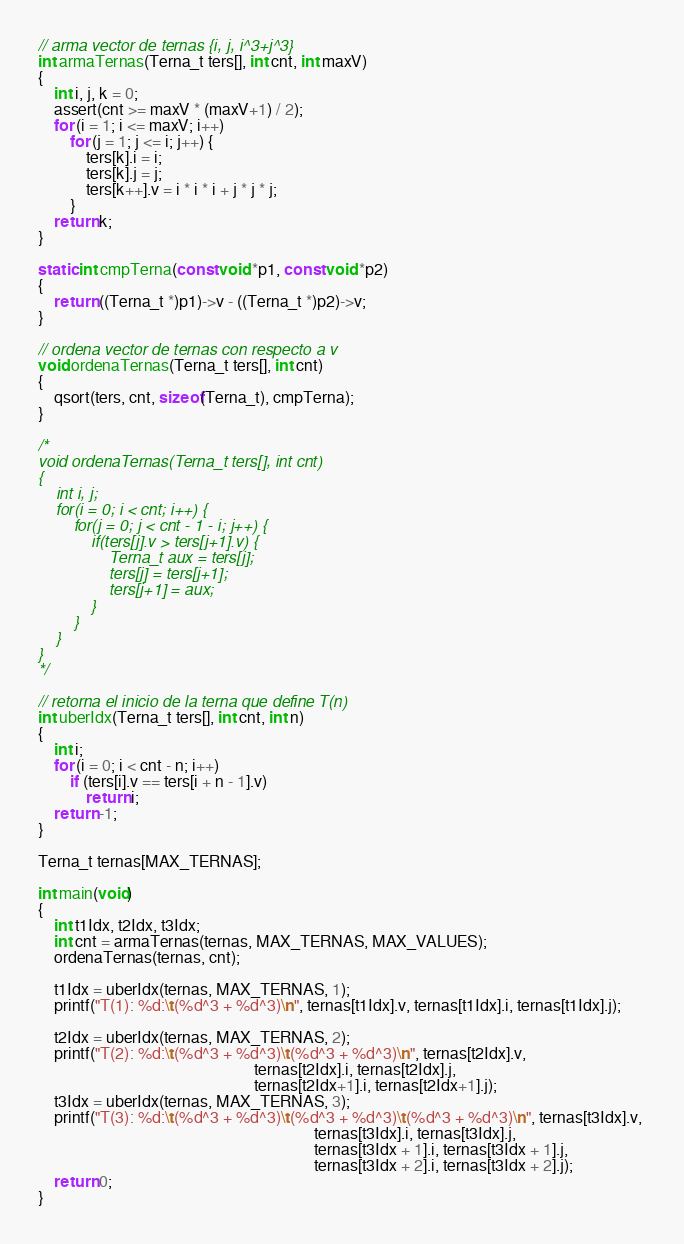Convert code to text. <code><loc_0><loc_0><loc_500><loc_500><_C_>
// arma vector de ternas {i, j, i^3+j^3}
int armaTernas(Terna_t ters[], int cnt, int maxV)
{
    int i, j, k = 0;
    assert(cnt >= maxV * (maxV+1) / 2);
    for (i = 1; i <= maxV; i++) 
        for (j = 1; j <= i; j++) {
            ters[k].i = i;
            ters[k].j = j;
            ters[k++].v = i * i * i + j * j * j;
        }
    return k;
}

static int cmpTerna(const void *p1, const void *p2)
{
    return ((Terna_t *)p1)->v - ((Terna_t *)p2)->v;
}

// ordena vector de ternas con respecto a v
void ordenaTernas(Terna_t ters[], int cnt)
{
    qsort(ters, cnt, sizeof(Terna_t), cmpTerna);
}

/*
void ordenaTernas(Terna_t ters[], int cnt)
{
    int i, j;
    for(i = 0; i < cnt; i++) {
        for(j = 0; j < cnt - 1 - i; j++) {
            if(ters[j].v > ters[j+1].v) {
                Terna_t aux = ters[j];
                ters[j] = ters[j+1];
                ters[j+1] = aux;
            }
        }
    }
}
*/

// retorna el inicio de la terna que define T(n)
int uberIdx(Terna_t ters[], int cnt, int n)
{
    int i;
    for (i = 0; i < cnt - n; i++) 
        if (ters[i].v == ters[i + n - 1].v)
            return i;
    return -1;
}

Terna_t ternas[MAX_TERNAS];

int main(void)
{
    int t1Idx, t2Idx, t3Idx;
    int cnt = armaTernas(ternas, MAX_TERNAS, MAX_VALUES);
    ordenaTernas(ternas, cnt);
    
    t1Idx = uberIdx(ternas, MAX_TERNAS, 1);
    printf("T(1): %d:\t(%d^3 + %d^3)\n", ternas[t1Idx].v, ternas[t1Idx].i, ternas[t1Idx].j);
    
    t2Idx = uberIdx(ternas, MAX_TERNAS, 2);
    printf("T(2): %d:\t(%d^3 + %d^3)\t(%d^3 + %d^3)\n", ternas[t2Idx].v, 
                                                      ternas[t2Idx].i, ternas[t2Idx].j, 
                                                      ternas[t2Idx+1].i, ternas[t2Idx+1].j);
    t3Idx = uberIdx(ternas, MAX_TERNAS, 3);
    printf("T(3): %d:\t(%d^3 + %d^3)\t(%d^3 + %d^3)\t(%d^3 + %d^3)\n", ternas[t3Idx].v, 
                                                                     ternas[t3Idx].i, ternas[t3Idx].j, 
                                                                     ternas[t3Idx + 1].i, ternas[t3Idx + 1].j, 
                                                                     ternas[t3Idx + 2].i, ternas[t3Idx + 2].j);
    return 0;
}

</code> 